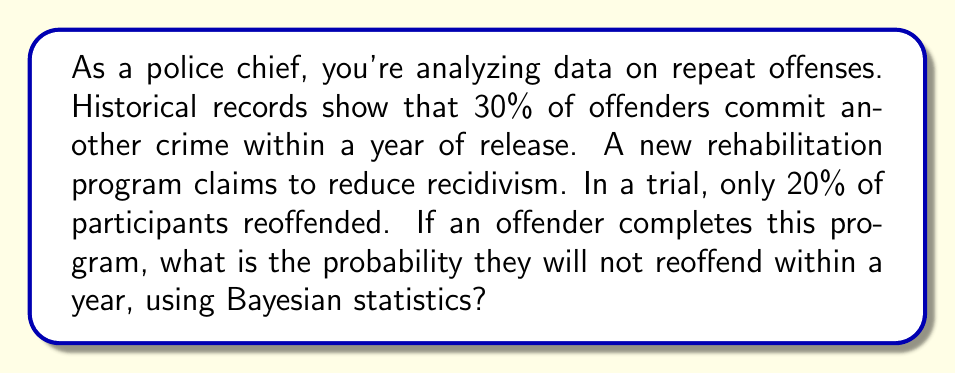Show me your answer to this math problem. Let's approach this problem using Bayes' theorem:

1) Define our events:
   A: The offender does not reoffend
   B: The offender completed the rehabilitation program

2) We know:
   P(B|not A) = 0.2 (20% of program participants reoffended)
   P(not A) = 0.3 (30% of offenders reoffend in general)
   P(A) = 1 - P(not A) = 0.7

3) We need to find P(A|B) using Bayes' theorem:

   $$P(A|B) = \frac{P(B|A) \cdot P(A)}{P(B)}$$

4) We can calculate P(B|A) using the given P(B|not A):
   P(B|A) = 1 - P(B|not A) = 1 - 0.2 = 0.8

5) We need to find P(B) using the law of total probability:
   $$P(B) = P(B|A) \cdot P(A) + P(B|not A) \cdot P(not A)$$
   $$P(B) = 0.8 \cdot 0.7 + 0.2 \cdot 0.3 = 0.56 + 0.06 = 0.62$$

6) Now we can apply Bayes' theorem:
   $$P(A|B) = \frac{0.8 \cdot 0.7}{0.62} \approx 0.9032$$

Therefore, the probability that an offender who completed the program will not reoffend within a year is approximately 0.9032 or 90.32%.
Answer: 0.9032 (or 90.32%) 